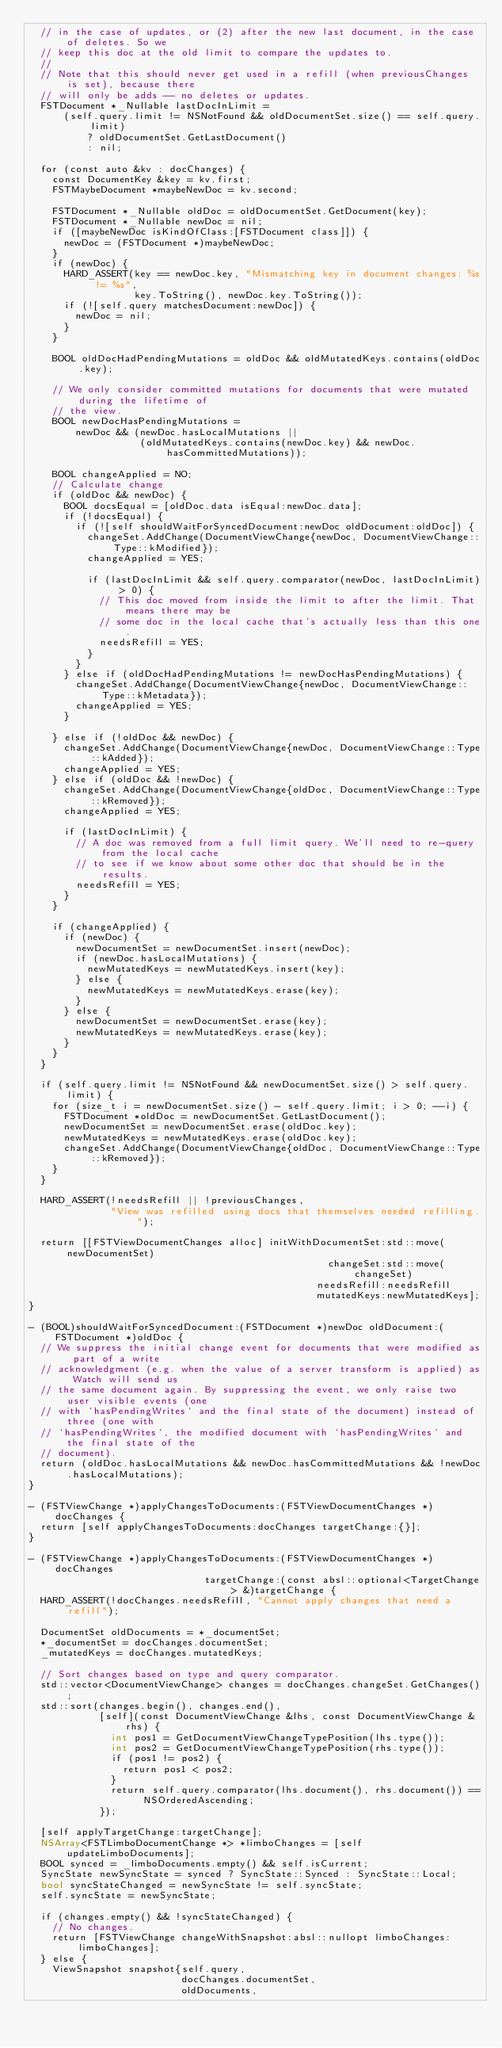<code> <loc_0><loc_0><loc_500><loc_500><_ObjectiveC_>  // in the case of updates, or (2) after the new last document, in the case of deletes. So we
  // keep this doc at the old limit to compare the updates to.
  //
  // Note that this should never get used in a refill (when previousChanges is set), because there
  // will only be adds -- no deletes or updates.
  FSTDocument *_Nullable lastDocInLimit =
      (self.query.limit != NSNotFound && oldDocumentSet.size() == self.query.limit)
          ? oldDocumentSet.GetLastDocument()
          : nil;

  for (const auto &kv : docChanges) {
    const DocumentKey &key = kv.first;
    FSTMaybeDocument *maybeNewDoc = kv.second;

    FSTDocument *_Nullable oldDoc = oldDocumentSet.GetDocument(key);
    FSTDocument *_Nullable newDoc = nil;
    if ([maybeNewDoc isKindOfClass:[FSTDocument class]]) {
      newDoc = (FSTDocument *)maybeNewDoc;
    }
    if (newDoc) {
      HARD_ASSERT(key == newDoc.key, "Mismatching key in document changes: %s != %s",
                  key.ToString(), newDoc.key.ToString());
      if (![self.query matchesDocument:newDoc]) {
        newDoc = nil;
      }
    }

    BOOL oldDocHadPendingMutations = oldDoc && oldMutatedKeys.contains(oldDoc.key);

    // We only consider committed mutations for documents that were mutated during the lifetime of
    // the view.
    BOOL newDocHasPendingMutations =
        newDoc && (newDoc.hasLocalMutations ||
                   (oldMutatedKeys.contains(newDoc.key) && newDoc.hasCommittedMutations));

    BOOL changeApplied = NO;
    // Calculate change
    if (oldDoc && newDoc) {
      BOOL docsEqual = [oldDoc.data isEqual:newDoc.data];
      if (!docsEqual) {
        if (![self shouldWaitForSyncedDocument:newDoc oldDocument:oldDoc]) {
          changeSet.AddChange(DocumentViewChange{newDoc, DocumentViewChange::Type::kModified});
          changeApplied = YES;

          if (lastDocInLimit && self.query.comparator(newDoc, lastDocInLimit) > 0) {
            // This doc moved from inside the limit to after the limit. That means there may be
            // some doc in the local cache that's actually less than this one.
            needsRefill = YES;
          }
        }
      } else if (oldDocHadPendingMutations != newDocHasPendingMutations) {
        changeSet.AddChange(DocumentViewChange{newDoc, DocumentViewChange::Type::kMetadata});
        changeApplied = YES;
      }

    } else if (!oldDoc && newDoc) {
      changeSet.AddChange(DocumentViewChange{newDoc, DocumentViewChange::Type::kAdded});
      changeApplied = YES;
    } else if (oldDoc && !newDoc) {
      changeSet.AddChange(DocumentViewChange{oldDoc, DocumentViewChange::Type::kRemoved});
      changeApplied = YES;

      if (lastDocInLimit) {
        // A doc was removed from a full limit query. We'll need to re-query from the local cache
        // to see if we know about some other doc that should be in the results.
        needsRefill = YES;
      }
    }

    if (changeApplied) {
      if (newDoc) {
        newDocumentSet = newDocumentSet.insert(newDoc);
        if (newDoc.hasLocalMutations) {
          newMutatedKeys = newMutatedKeys.insert(key);
        } else {
          newMutatedKeys = newMutatedKeys.erase(key);
        }
      } else {
        newDocumentSet = newDocumentSet.erase(key);
        newMutatedKeys = newMutatedKeys.erase(key);
      }
    }
  }

  if (self.query.limit != NSNotFound && newDocumentSet.size() > self.query.limit) {
    for (size_t i = newDocumentSet.size() - self.query.limit; i > 0; --i) {
      FSTDocument *oldDoc = newDocumentSet.GetLastDocument();
      newDocumentSet = newDocumentSet.erase(oldDoc.key);
      newMutatedKeys = newMutatedKeys.erase(oldDoc.key);
      changeSet.AddChange(DocumentViewChange{oldDoc, DocumentViewChange::Type::kRemoved});
    }
  }

  HARD_ASSERT(!needsRefill || !previousChanges,
              "View was refilled using docs that themselves needed refilling.");

  return [[FSTViewDocumentChanges alloc] initWithDocumentSet:std::move(newDocumentSet)
                                                   changeSet:std::move(changeSet)
                                                 needsRefill:needsRefill
                                                 mutatedKeys:newMutatedKeys];
}

- (BOOL)shouldWaitForSyncedDocument:(FSTDocument *)newDoc oldDocument:(FSTDocument *)oldDoc {
  // We suppress the initial change event for documents that were modified as part of a write
  // acknowledgment (e.g. when the value of a server transform is applied) as Watch will send us
  // the same document again. By suppressing the event, we only raise two user visible events (one
  // with `hasPendingWrites` and the final state of the document) instead of three (one with
  // `hasPendingWrites`, the modified document with `hasPendingWrites` and the final state of the
  // document).
  return (oldDoc.hasLocalMutations && newDoc.hasCommittedMutations && !newDoc.hasLocalMutations);
}

- (FSTViewChange *)applyChangesToDocuments:(FSTViewDocumentChanges *)docChanges {
  return [self applyChangesToDocuments:docChanges targetChange:{}];
}

- (FSTViewChange *)applyChangesToDocuments:(FSTViewDocumentChanges *)docChanges
                              targetChange:(const absl::optional<TargetChange> &)targetChange {
  HARD_ASSERT(!docChanges.needsRefill, "Cannot apply changes that need a refill");

  DocumentSet oldDocuments = *_documentSet;
  *_documentSet = docChanges.documentSet;
  _mutatedKeys = docChanges.mutatedKeys;

  // Sort changes based on type and query comparator.
  std::vector<DocumentViewChange> changes = docChanges.changeSet.GetChanges();
  std::sort(changes.begin(), changes.end(),
            [self](const DocumentViewChange &lhs, const DocumentViewChange &rhs) {
              int pos1 = GetDocumentViewChangeTypePosition(lhs.type());
              int pos2 = GetDocumentViewChangeTypePosition(rhs.type());
              if (pos1 != pos2) {
                return pos1 < pos2;
              }
              return self.query.comparator(lhs.document(), rhs.document()) == NSOrderedAscending;
            });

  [self applyTargetChange:targetChange];
  NSArray<FSTLimboDocumentChange *> *limboChanges = [self updateLimboDocuments];
  BOOL synced = _limboDocuments.empty() && self.isCurrent;
  SyncState newSyncState = synced ? SyncState::Synced : SyncState::Local;
  bool syncStateChanged = newSyncState != self.syncState;
  self.syncState = newSyncState;

  if (changes.empty() && !syncStateChanged) {
    // No changes.
    return [FSTViewChange changeWithSnapshot:absl::nullopt limboChanges:limboChanges];
  } else {
    ViewSnapshot snapshot{self.query,
                          docChanges.documentSet,
                          oldDocuments,</code> 